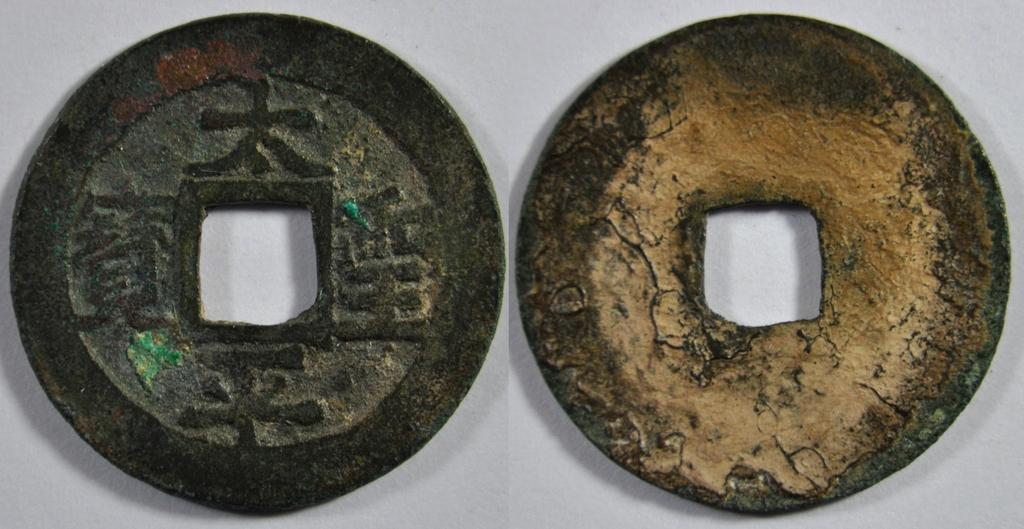How many circular objects are present in the image? There are two circular objects in the image. What might the circular objects represent? The circular objects appear to be coins. What type of car does the sister drive in the image? There is no sister or car present in the image; it only contains two circular objects that appear to be coins. 